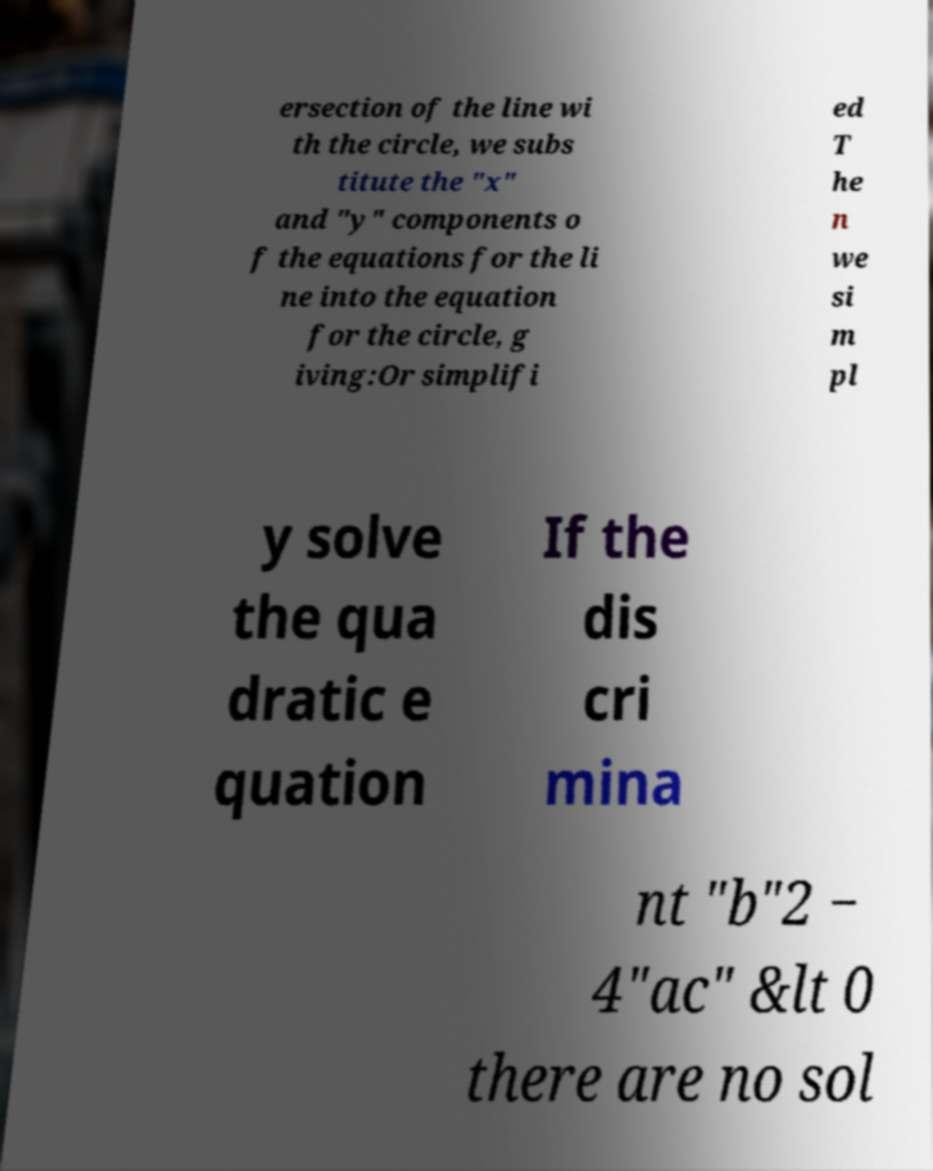Could you assist in decoding the text presented in this image and type it out clearly? ersection of the line wi th the circle, we subs titute the "x" and "y" components o f the equations for the li ne into the equation for the circle, g iving:Or simplifi ed T he n we si m pl y solve the qua dratic e quation If the dis cri mina nt "b"2 − 4"ac" &lt 0 there are no sol 